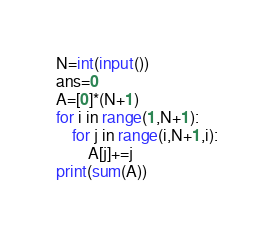Convert code to text. <code><loc_0><loc_0><loc_500><loc_500><_Python_>N=int(input())
ans=0
A=[0]*(N+1)
for i in range(1,N+1):
    for j in range(i,N+1,i):
        A[j]+=j
print(sum(A))</code> 